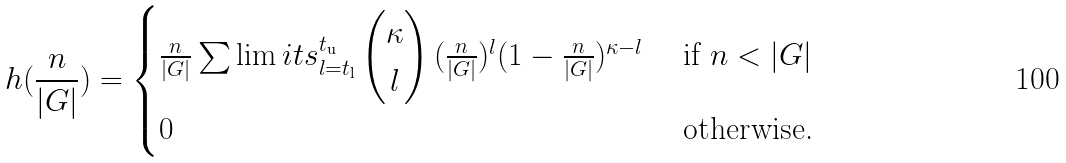<formula> <loc_0><loc_0><loc_500><loc_500>h ( \frac { n } { | G | } ) = \begin{cases} \frac { n } { | G | } \sum \lim i t s ^ { t _ { \text {u} } } _ { l = t _ { \text {l} } } \begin{pmatrix} \kappa \\ l \end{pmatrix} ( \frac { n } { | G | } ) ^ { l } ( 1 - \frac { n } { | G | } ) ^ { \kappa - l } & \text { if $n<|G|$} \\ 0 & \text { otherwise.} \end{cases}</formula> 